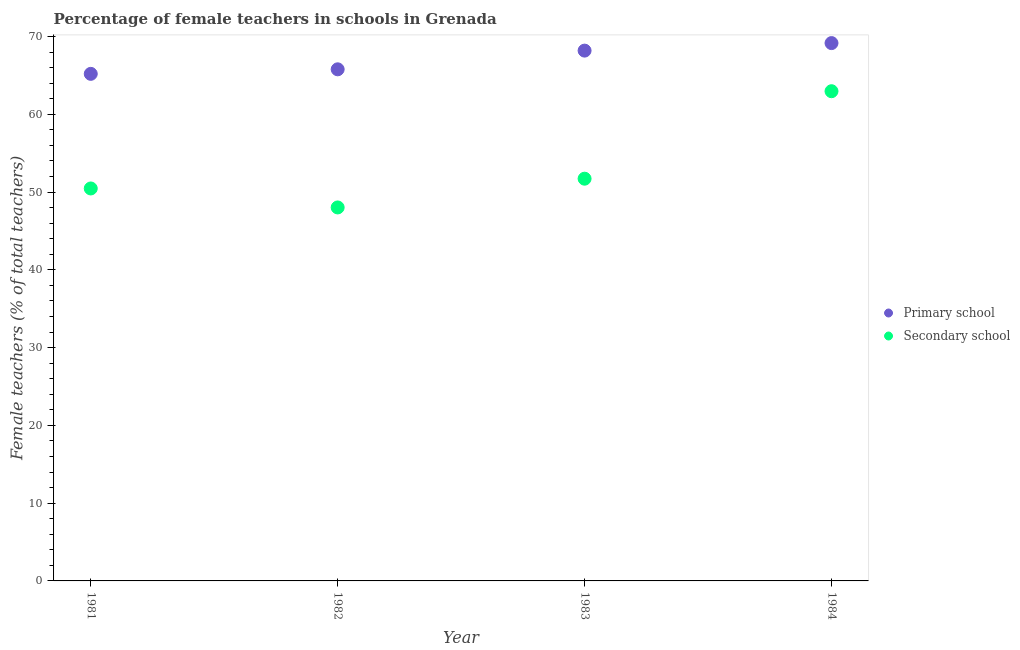What is the percentage of female teachers in primary schools in 1982?
Keep it short and to the point. 65.79. Across all years, what is the maximum percentage of female teachers in secondary schools?
Provide a short and direct response. 62.97. Across all years, what is the minimum percentage of female teachers in primary schools?
Ensure brevity in your answer.  65.21. What is the total percentage of female teachers in primary schools in the graph?
Give a very brief answer. 268.35. What is the difference between the percentage of female teachers in primary schools in 1982 and that in 1984?
Keep it short and to the point. -3.37. What is the difference between the percentage of female teachers in secondary schools in 1982 and the percentage of female teachers in primary schools in 1983?
Ensure brevity in your answer.  -20.17. What is the average percentage of female teachers in secondary schools per year?
Give a very brief answer. 53.3. In the year 1982, what is the difference between the percentage of female teachers in secondary schools and percentage of female teachers in primary schools?
Give a very brief answer. -17.76. In how many years, is the percentage of female teachers in primary schools greater than 22 %?
Your answer should be compact. 4. What is the ratio of the percentage of female teachers in primary schools in 1982 to that in 1983?
Offer a terse response. 0.96. Is the difference between the percentage of female teachers in primary schools in 1982 and 1983 greater than the difference between the percentage of female teachers in secondary schools in 1982 and 1983?
Provide a succinct answer. Yes. What is the difference between the highest and the second highest percentage of female teachers in primary schools?
Keep it short and to the point. 0.97. What is the difference between the highest and the lowest percentage of female teachers in primary schools?
Keep it short and to the point. 3.96. Is the sum of the percentage of female teachers in primary schools in 1983 and 1984 greater than the maximum percentage of female teachers in secondary schools across all years?
Keep it short and to the point. Yes. Does the percentage of female teachers in secondary schools monotonically increase over the years?
Provide a short and direct response. No. Is the percentage of female teachers in primary schools strictly greater than the percentage of female teachers in secondary schools over the years?
Your answer should be very brief. Yes. How many years are there in the graph?
Your answer should be very brief. 4. What is the difference between two consecutive major ticks on the Y-axis?
Your answer should be compact. 10. Are the values on the major ticks of Y-axis written in scientific E-notation?
Provide a succinct answer. No. Does the graph contain any zero values?
Your answer should be compact. No. How many legend labels are there?
Provide a succinct answer. 2. What is the title of the graph?
Your response must be concise. Percentage of female teachers in schools in Grenada. What is the label or title of the Y-axis?
Your answer should be very brief. Female teachers (% of total teachers). What is the Female teachers (% of total teachers) in Primary school in 1981?
Provide a short and direct response. 65.21. What is the Female teachers (% of total teachers) in Secondary school in 1981?
Provide a short and direct response. 50.47. What is the Female teachers (% of total teachers) of Primary school in 1982?
Your response must be concise. 65.79. What is the Female teachers (% of total teachers) in Secondary school in 1982?
Your answer should be very brief. 48.03. What is the Female teachers (% of total teachers) in Primary school in 1983?
Your answer should be compact. 68.19. What is the Female teachers (% of total teachers) in Secondary school in 1983?
Provide a succinct answer. 51.72. What is the Female teachers (% of total teachers) in Primary school in 1984?
Give a very brief answer. 69.16. What is the Female teachers (% of total teachers) in Secondary school in 1984?
Give a very brief answer. 62.97. Across all years, what is the maximum Female teachers (% of total teachers) of Primary school?
Your answer should be very brief. 69.16. Across all years, what is the maximum Female teachers (% of total teachers) of Secondary school?
Offer a very short reply. 62.97. Across all years, what is the minimum Female teachers (% of total teachers) in Primary school?
Your response must be concise. 65.21. Across all years, what is the minimum Female teachers (% of total teachers) of Secondary school?
Keep it short and to the point. 48.03. What is the total Female teachers (% of total teachers) in Primary school in the graph?
Offer a terse response. 268.35. What is the total Female teachers (% of total teachers) of Secondary school in the graph?
Give a very brief answer. 213.19. What is the difference between the Female teachers (% of total teachers) of Primary school in 1981 and that in 1982?
Make the answer very short. -0.58. What is the difference between the Female teachers (% of total teachers) in Secondary school in 1981 and that in 1982?
Keep it short and to the point. 2.44. What is the difference between the Female teachers (% of total teachers) in Primary school in 1981 and that in 1983?
Make the answer very short. -2.99. What is the difference between the Female teachers (% of total teachers) of Secondary school in 1981 and that in 1983?
Provide a short and direct response. -1.26. What is the difference between the Female teachers (% of total teachers) in Primary school in 1981 and that in 1984?
Give a very brief answer. -3.96. What is the difference between the Female teachers (% of total teachers) of Secondary school in 1981 and that in 1984?
Your answer should be compact. -12.51. What is the difference between the Female teachers (% of total teachers) in Primary school in 1982 and that in 1983?
Give a very brief answer. -2.4. What is the difference between the Female teachers (% of total teachers) in Secondary school in 1982 and that in 1983?
Your answer should be compact. -3.7. What is the difference between the Female teachers (% of total teachers) of Primary school in 1982 and that in 1984?
Keep it short and to the point. -3.37. What is the difference between the Female teachers (% of total teachers) in Secondary school in 1982 and that in 1984?
Ensure brevity in your answer.  -14.95. What is the difference between the Female teachers (% of total teachers) of Primary school in 1983 and that in 1984?
Give a very brief answer. -0.97. What is the difference between the Female teachers (% of total teachers) of Secondary school in 1983 and that in 1984?
Provide a succinct answer. -11.25. What is the difference between the Female teachers (% of total teachers) of Primary school in 1981 and the Female teachers (% of total teachers) of Secondary school in 1982?
Ensure brevity in your answer.  17.18. What is the difference between the Female teachers (% of total teachers) in Primary school in 1981 and the Female teachers (% of total teachers) in Secondary school in 1983?
Your response must be concise. 13.48. What is the difference between the Female teachers (% of total teachers) of Primary school in 1981 and the Female teachers (% of total teachers) of Secondary school in 1984?
Make the answer very short. 2.23. What is the difference between the Female teachers (% of total teachers) of Primary school in 1982 and the Female teachers (% of total teachers) of Secondary school in 1983?
Offer a terse response. 14.07. What is the difference between the Female teachers (% of total teachers) in Primary school in 1982 and the Female teachers (% of total teachers) in Secondary school in 1984?
Provide a short and direct response. 2.82. What is the difference between the Female teachers (% of total teachers) of Primary school in 1983 and the Female teachers (% of total teachers) of Secondary school in 1984?
Your response must be concise. 5.22. What is the average Female teachers (% of total teachers) of Primary school per year?
Your response must be concise. 67.09. What is the average Female teachers (% of total teachers) in Secondary school per year?
Your answer should be compact. 53.3. In the year 1981, what is the difference between the Female teachers (% of total teachers) of Primary school and Female teachers (% of total teachers) of Secondary school?
Make the answer very short. 14.74. In the year 1982, what is the difference between the Female teachers (% of total teachers) in Primary school and Female teachers (% of total teachers) in Secondary school?
Offer a terse response. 17.76. In the year 1983, what is the difference between the Female teachers (% of total teachers) in Primary school and Female teachers (% of total teachers) in Secondary school?
Give a very brief answer. 16.47. In the year 1984, what is the difference between the Female teachers (% of total teachers) of Primary school and Female teachers (% of total teachers) of Secondary school?
Offer a very short reply. 6.19. What is the ratio of the Female teachers (% of total teachers) in Secondary school in 1981 to that in 1982?
Make the answer very short. 1.05. What is the ratio of the Female teachers (% of total teachers) of Primary school in 1981 to that in 1983?
Give a very brief answer. 0.96. What is the ratio of the Female teachers (% of total teachers) of Secondary school in 1981 to that in 1983?
Make the answer very short. 0.98. What is the ratio of the Female teachers (% of total teachers) of Primary school in 1981 to that in 1984?
Your response must be concise. 0.94. What is the ratio of the Female teachers (% of total teachers) in Secondary school in 1981 to that in 1984?
Keep it short and to the point. 0.8. What is the ratio of the Female teachers (% of total teachers) in Primary school in 1982 to that in 1983?
Offer a very short reply. 0.96. What is the ratio of the Female teachers (% of total teachers) of Secondary school in 1982 to that in 1983?
Provide a succinct answer. 0.93. What is the ratio of the Female teachers (% of total teachers) in Primary school in 1982 to that in 1984?
Your answer should be very brief. 0.95. What is the ratio of the Female teachers (% of total teachers) in Secondary school in 1982 to that in 1984?
Ensure brevity in your answer.  0.76. What is the ratio of the Female teachers (% of total teachers) in Primary school in 1983 to that in 1984?
Provide a succinct answer. 0.99. What is the ratio of the Female teachers (% of total teachers) in Secondary school in 1983 to that in 1984?
Keep it short and to the point. 0.82. What is the difference between the highest and the second highest Female teachers (% of total teachers) in Primary school?
Offer a very short reply. 0.97. What is the difference between the highest and the second highest Female teachers (% of total teachers) of Secondary school?
Offer a terse response. 11.25. What is the difference between the highest and the lowest Female teachers (% of total teachers) of Primary school?
Make the answer very short. 3.96. What is the difference between the highest and the lowest Female teachers (% of total teachers) in Secondary school?
Ensure brevity in your answer.  14.95. 